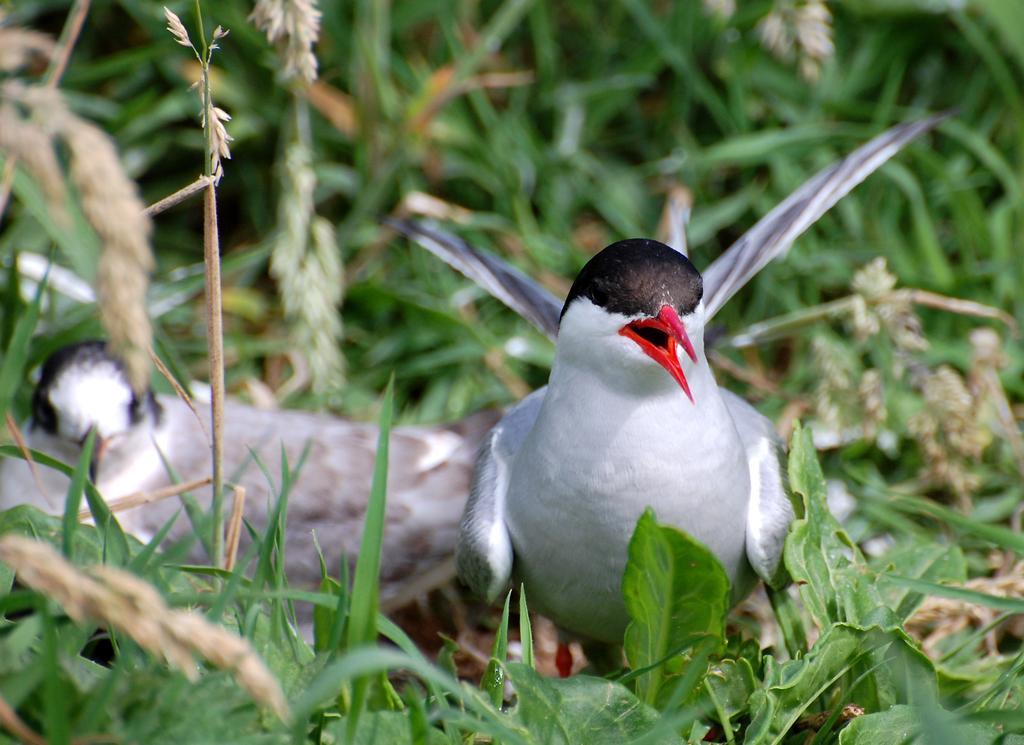Describe this image in one or two sentences. In this image we can see two white birds on the ground where we can see the grass. The background of the image is slightly blurred, where we can see the plants. 